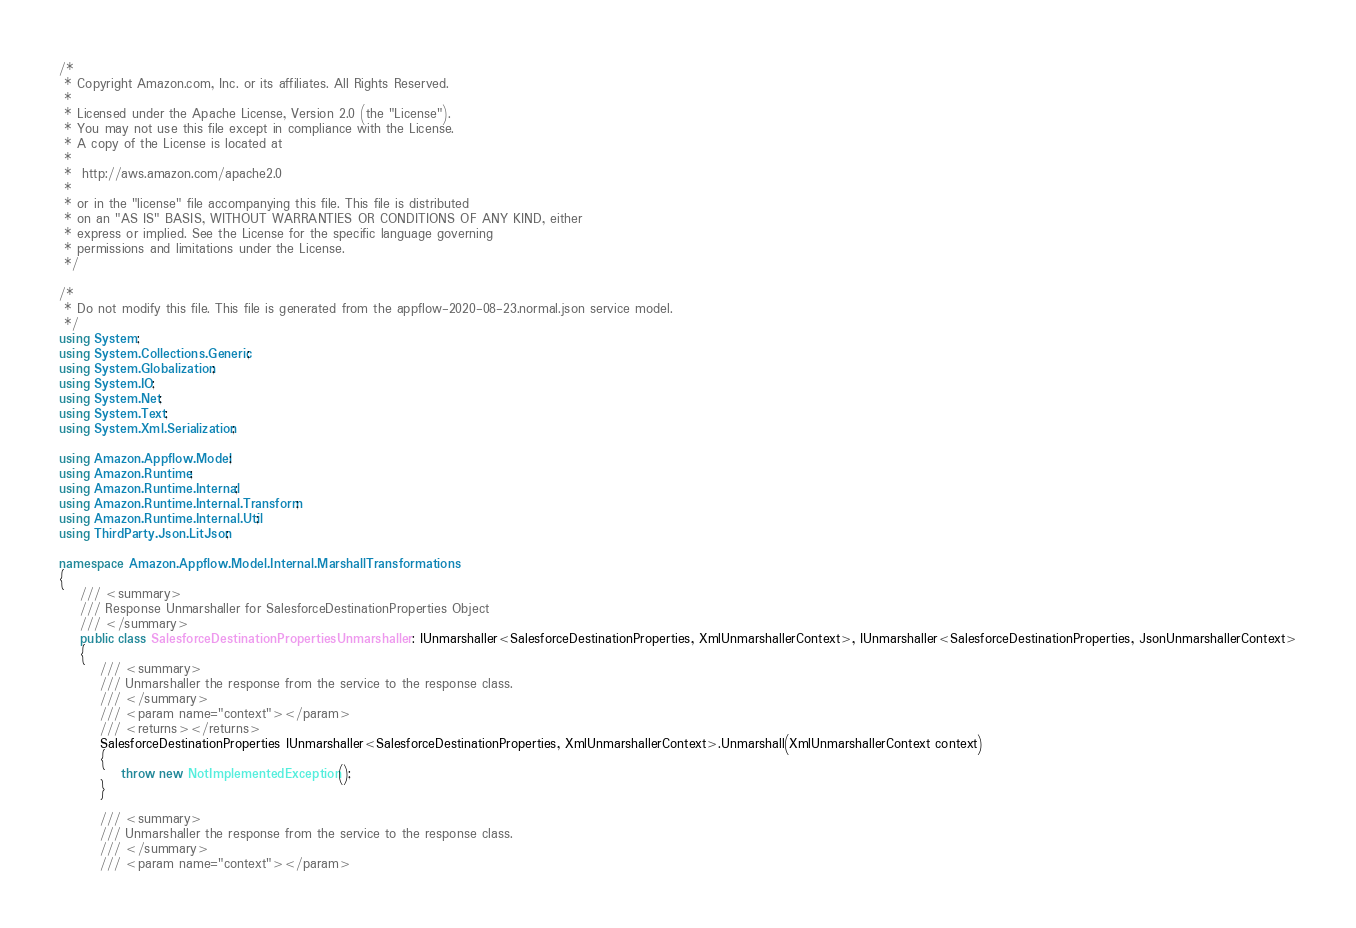<code> <loc_0><loc_0><loc_500><loc_500><_C#_>/*
 * Copyright Amazon.com, Inc. or its affiliates. All Rights Reserved.
 * 
 * Licensed under the Apache License, Version 2.0 (the "License").
 * You may not use this file except in compliance with the License.
 * A copy of the License is located at
 * 
 *  http://aws.amazon.com/apache2.0
 * 
 * or in the "license" file accompanying this file. This file is distributed
 * on an "AS IS" BASIS, WITHOUT WARRANTIES OR CONDITIONS OF ANY KIND, either
 * express or implied. See the License for the specific language governing
 * permissions and limitations under the License.
 */

/*
 * Do not modify this file. This file is generated from the appflow-2020-08-23.normal.json service model.
 */
using System;
using System.Collections.Generic;
using System.Globalization;
using System.IO;
using System.Net;
using System.Text;
using System.Xml.Serialization;

using Amazon.Appflow.Model;
using Amazon.Runtime;
using Amazon.Runtime.Internal;
using Amazon.Runtime.Internal.Transform;
using Amazon.Runtime.Internal.Util;
using ThirdParty.Json.LitJson;

namespace Amazon.Appflow.Model.Internal.MarshallTransformations
{
    /// <summary>
    /// Response Unmarshaller for SalesforceDestinationProperties Object
    /// </summary>  
    public class SalesforceDestinationPropertiesUnmarshaller : IUnmarshaller<SalesforceDestinationProperties, XmlUnmarshallerContext>, IUnmarshaller<SalesforceDestinationProperties, JsonUnmarshallerContext>
    {
        /// <summary>
        /// Unmarshaller the response from the service to the response class.
        /// </summary>  
        /// <param name="context"></param>
        /// <returns></returns>
        SalesforceDestinationProperties IUnmarshaller<SalesforceDestinationProperties, XmlUnmarshallerContext>.Unmarshall(XmlUnmarshallerContext context)
        {
            throw new NotImplementedException();
        }

        /// <summary>
        /// Unmarshaller the response from the service to the response class.
        /// </summary>  
        /// <param name="context"></param></code> 